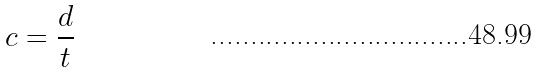<formula> <loc_0><loc_0><loc_500><loc_500>c = \frac { d } { t }</formula> 